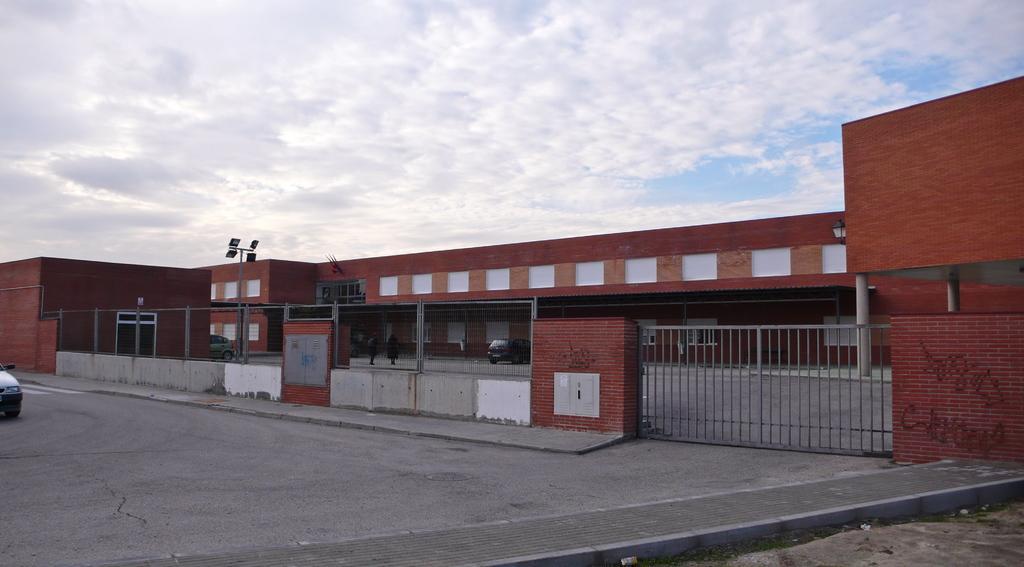Can you describe this image briefly? In this image we can see a building, gate. At the bottom of the image there is road. To the left side of the image there is car. At the top of the image there is sky and clouds. 